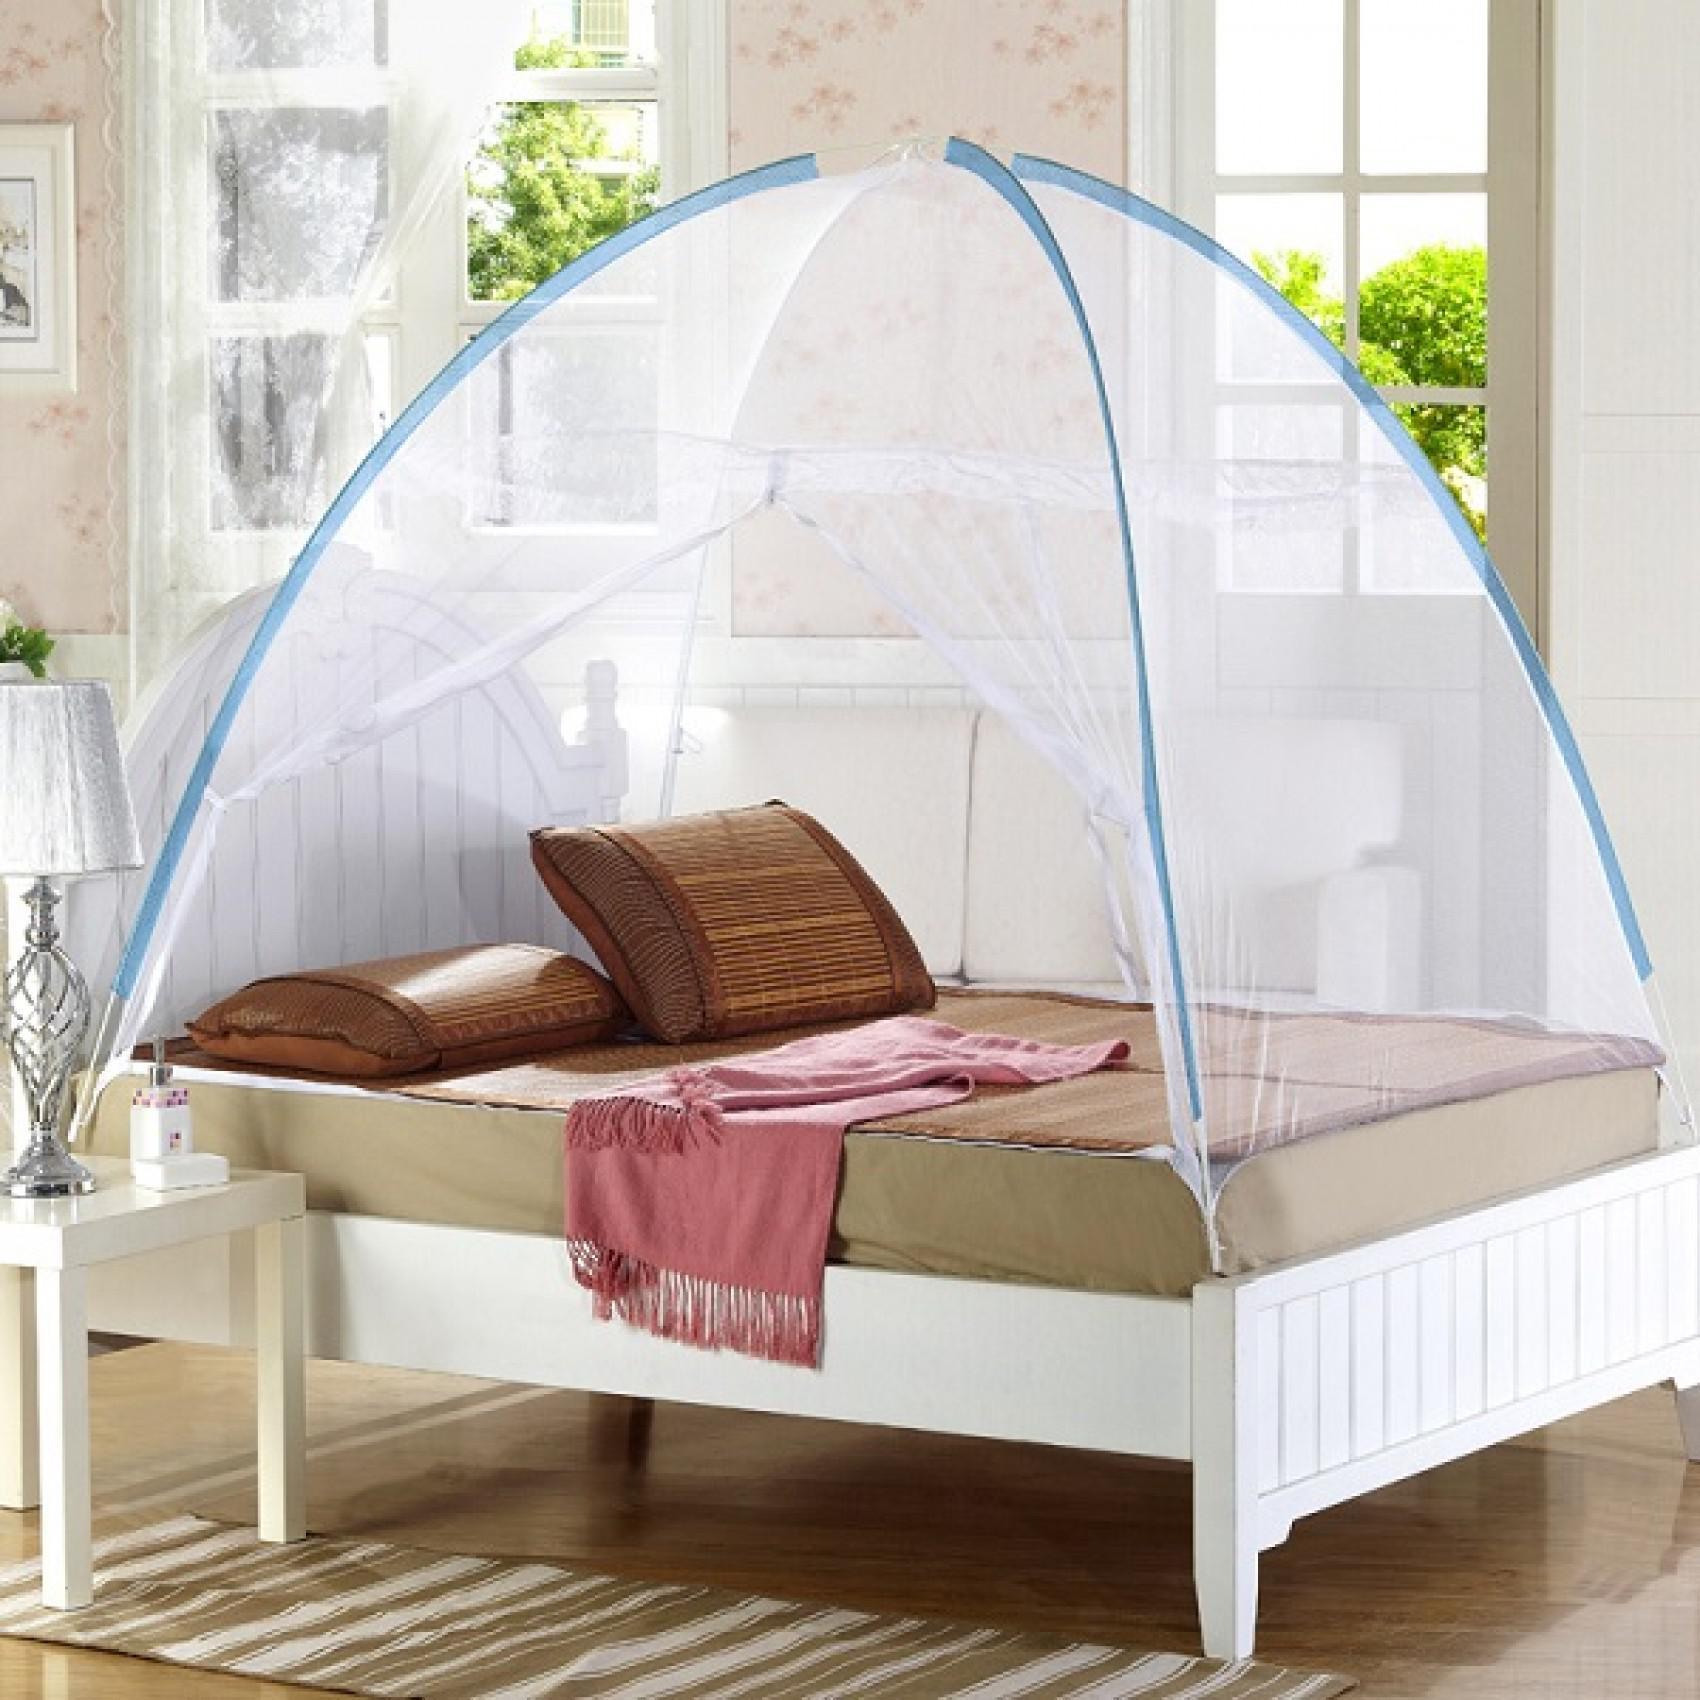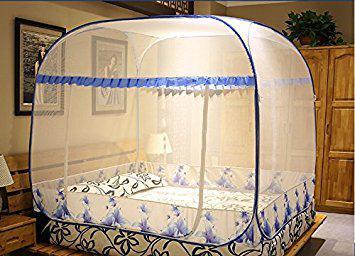The first image is the image on the left, the second image is the image on the right. Analyze the images presented: Is the assertion "Beds are draped in a gauzy material that hangs from a central point in the ceiling over each bed." valid? Answer yes or no. No. 